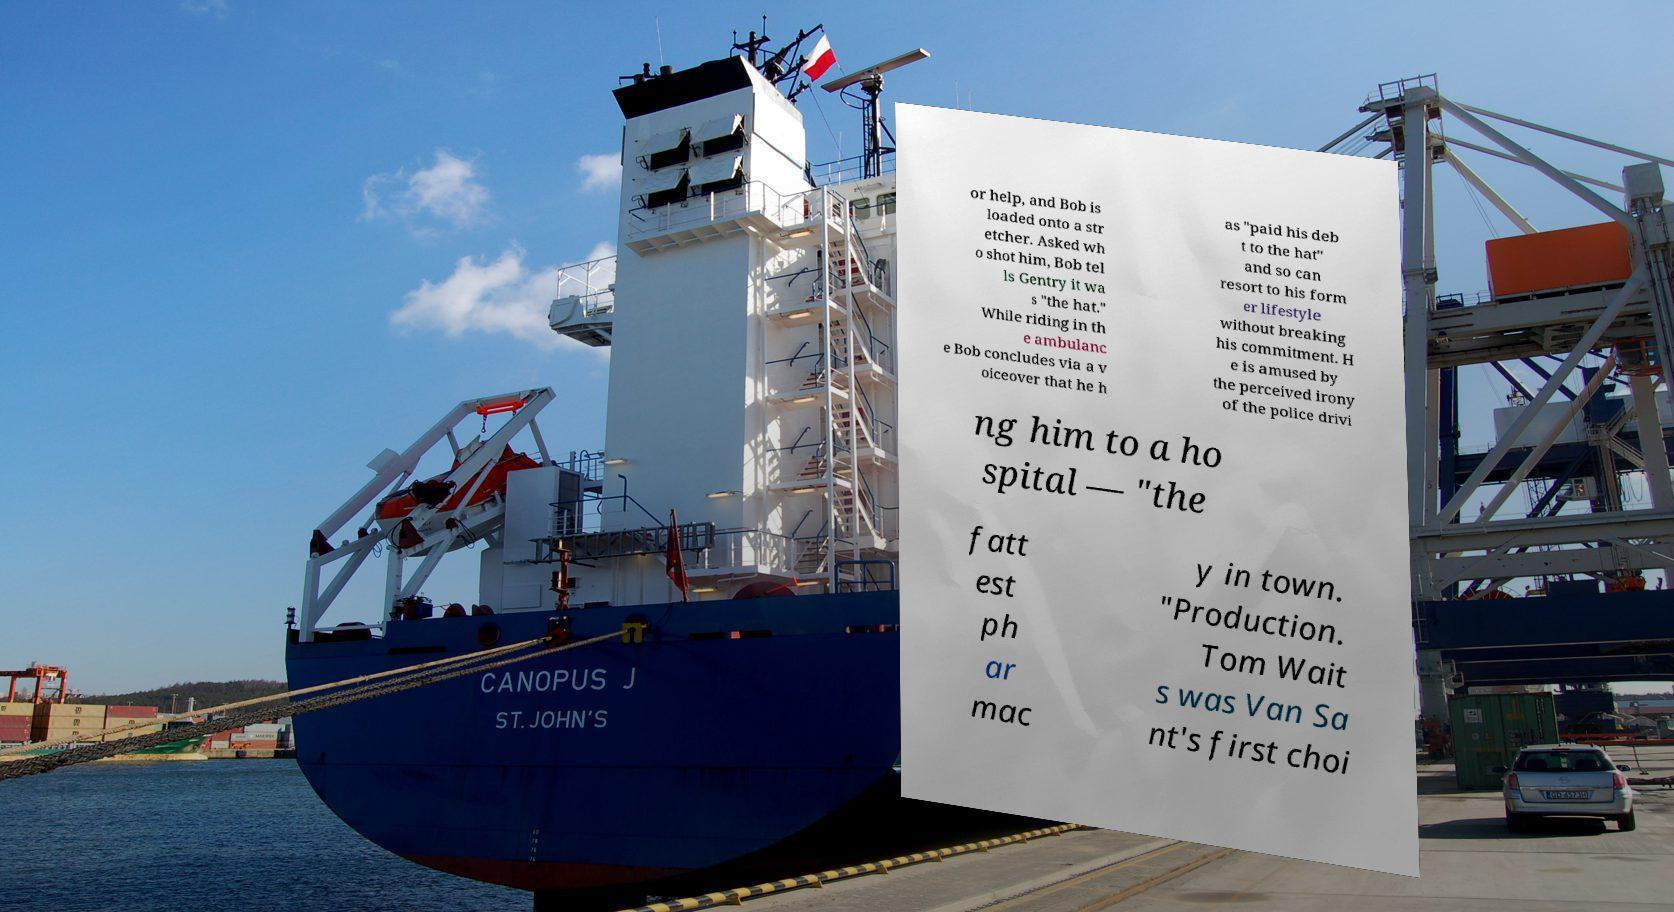Could you assist in decoding the text presented in this image and type it out clearly? or help, and Bob is loaded onto a str etcher. Asked wh o shot him, Bob tel ls Gentry it wa s "the hat." While riding in th e ambulanc e Bob concludes via a v oiceover that he h as "paid his deb t to the hat" and so can resort to his form er lifestyle without breaking his commitment. H e is amused by the perceived irony of the police drivi ng him to a ho spital — "the fatt est ph ar mac y in town. "Production. Tom Wait s was Van Sa nt's first choi 